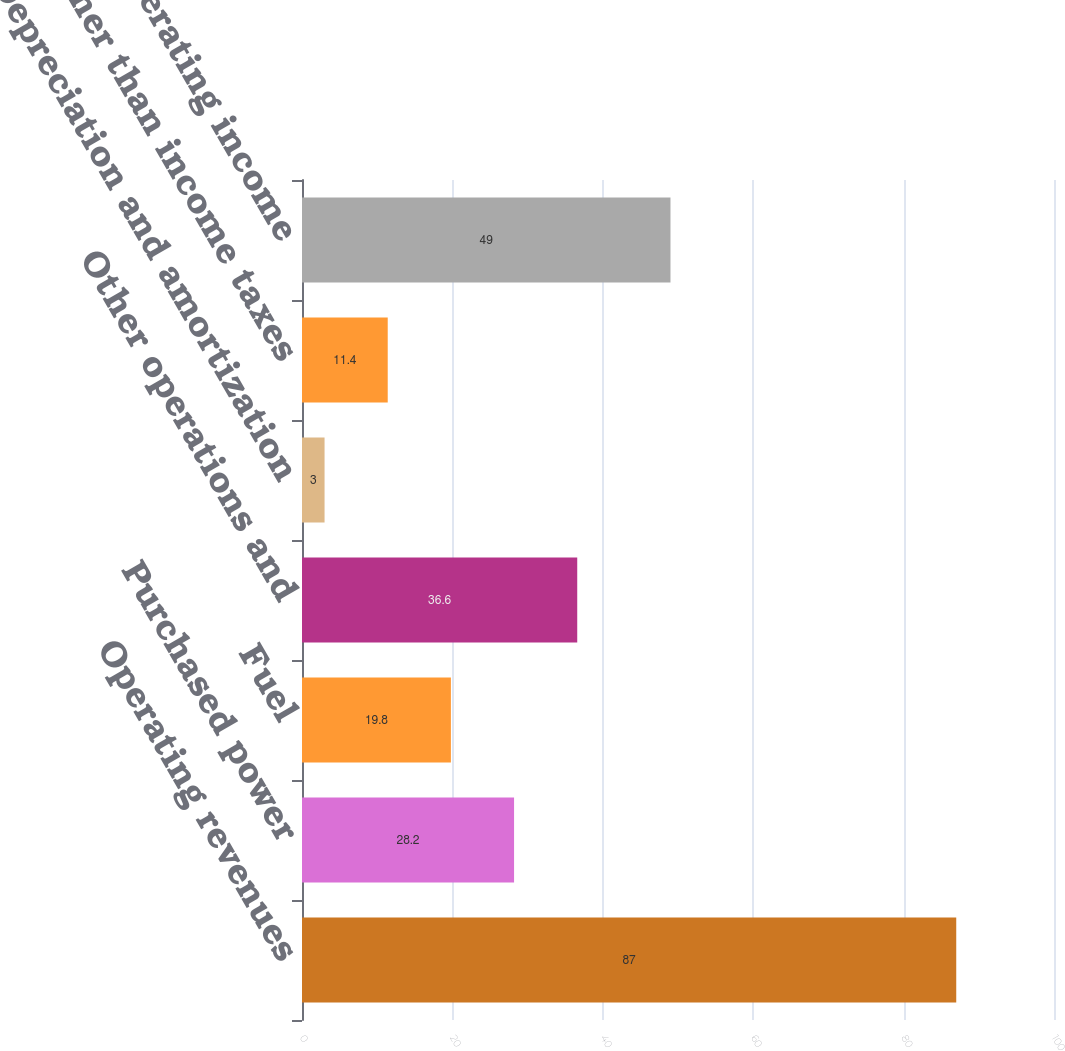Convert chart to OTSL. <chart><loc_0><loc_0><loc_500><loc_500><bar_chart><fcel>Operating revenues<fcel>Purchased power<fcel>Fuel<fcel>Other operations and<fcel>Depreciation and amortization<fcel>Taxes other than income taxes<fcel>Steam operating income<nl><fcel>87<fcel>28.2<fcel>19.8<fcel>36.6<fcel>3<fcel>11.4<fcel>49<nl></chart> 